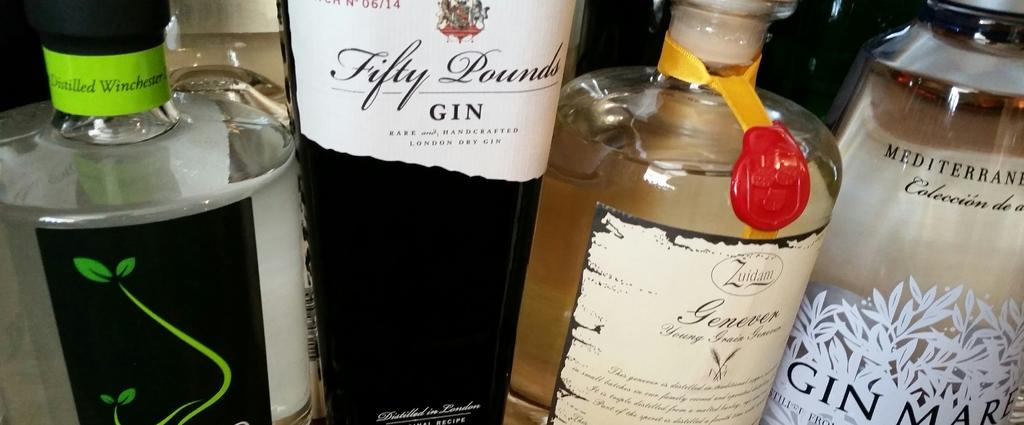<image>
Give a short and clear explanation of the subsequent image. Four gin bottles next to each other, including Distilled Westchester, Fifty Pounds, Genever, 